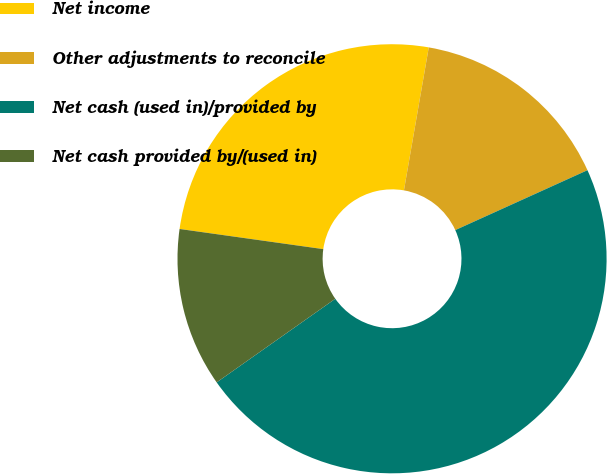Convert chart. <chart><loc_0><loc_0><loc_500><loc_500><pie_chart><fcel>Net income<fcel>Other adjustments to reconcile<fcel>Net cash (used in)/provided by<fcel>Net cash provided by/(used in)<nl><fcel>25.52%<fcel>15.49%<fcel>47.0%<fcel>11.99%<nl></chart> 